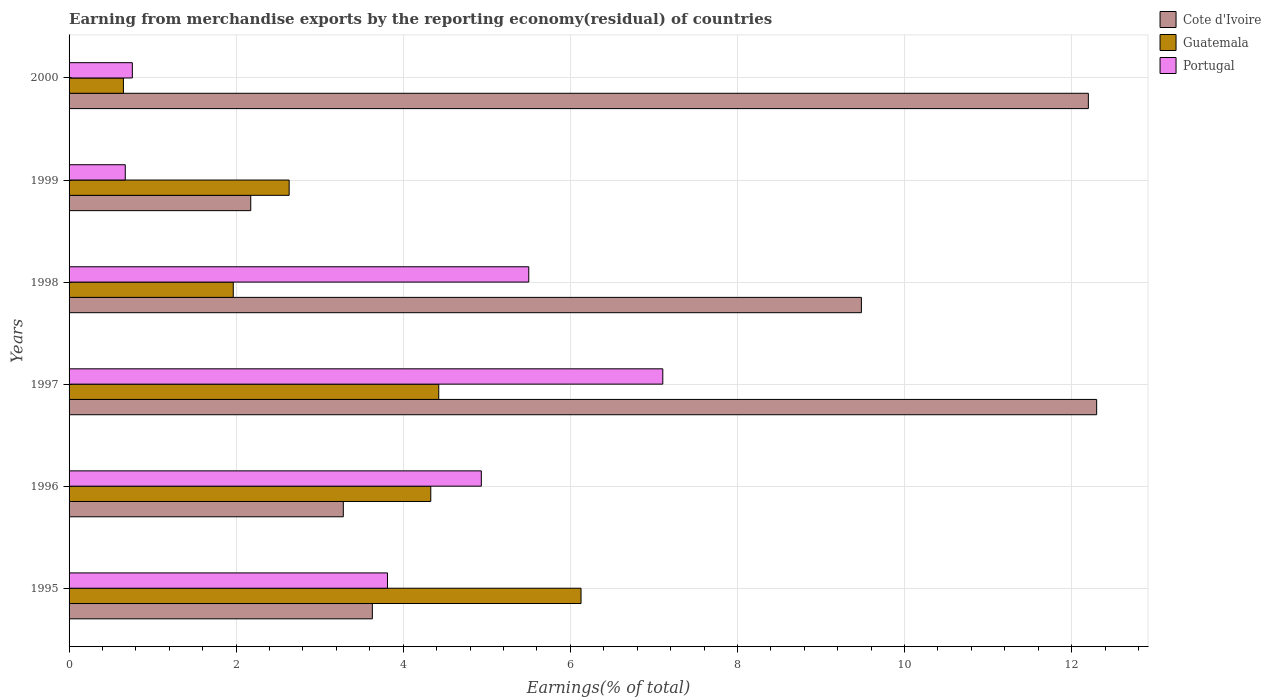How many different coloured bars are there?
Keep it short and to the point. 3. Are the number of bars on each tick of the Y-axis equal?
Offer a very short reply. Yes. How many bars are there on the 4th tick from the top?
Your response must be concise. 3. How many bars are there on the 1st tick from the bottom?
Your answer should be compact. 3. What is the label of the 3rd group of bars from the top?
Offer a terse response. 1998. In how many cases, is the number of bars for a given year not equal to the number of legend labels?
Provide a short and direct response. 0. What is the percentage of amount earned from merchandise exports in Guatemala in 1997?
Keep it short and to the point. 4.43. Across all years, what is the maximum percentage of amount earned from merchandise exports in Portugal?
Offer a very short reply. 7.11. Across all years, what is the minimum percentage of amount earned from merchandise exports in Portugal?
Offer a very short reply. 0.67. In which year was the percentage of amount earned from merchandise exports in Guatemala maximum?
Provide a short and direct response. 1995. In which year was the percentage of amount earned from merchandise exports in Guatemala minimum?
Provide a succinct answer. 2000. What is the total percentage of amount earned from merchandise exports in Guatemala in the graph?
Ensure brevity in your answer.  20.13. What is the difference between the percentage of amount earned from merchandise exports in Cote d'Ivoire in 1998 and that in 1999?
Ensure brevity in your answer.  7.31. What is the difference between the percentage of amount earned from merchandise exports in Guatemala in 1996 and the percentage of amount earned from merchandise exports in Cote d'Ivoire in 1998?
Your answer should be compact. -5.15. What is the average percentage of amount earned from merchandise exports in Portugal per year?
Make the answer very short. 3.8. In the year 1996, what is the difference between the percentage of amount earned from merchandise exports in Cote d'Ivoire and percentage of amount earned from merchandise exports in Portugal?
Give a very brief answer. -1.65. What is the ratio of the percentage of amount earned from merchandise exports in Guatemala in 1998 to that in 2000?
Ensure brevity in your answer.  3.02. Is the percentage of amount earned from merchandise exports in Guatemala in 1998 less than that in 2000?
Your answer should be compact. No. What is the difference between the highest and the second highest percentage of amount earned from merchandise exports in Portugal?
Offer a very short reply. 1.6. What is the difference between the highest and the lowest percentage of amount earned from merchandise exports in Portugal?
Provide a succinct answer. 6.43. In how many years, is the percentage of amount earned from merchandise exports in Guatemala greater than the average percentage of amount earned from merchandise exports in Guatemala taken over all years?
Your answer should be compact. 3. What does the 3rd bar from the top in 1998 represents?
Keep it short and to the point. Cote d'Ivoire. What does the 1st bar from the bottom in 1996 represents?
Your answer should be compact. Cote d'Ivoire. Is it the case that in every year, the sum of the percentage of amount earned from merchandise exports in Cote d'Ivoire and percentage of amount earned from merchandise exports in Portugal is greater than the percentage of amount earned from merchandise exports in Guatemala?
Keep it short and to the point. Yes. Are all the bars in the graph horizontal?
Keep it short and to the point. Yes. What is the difference between two consecutive major ticks on the X-axis?
Keep it short and to the point. 2. Are the values on the major ticks of X-axis written in scientific E-notation?
Offer a terse response. No. Does the graph contain any zero values?
Your answer should be very brief. No. Does the graph contain grids?
Make the answer very short. Yes. How many legend labels are there?
Make the answer very short. 3. What is the title of the graph?
Make the answer very short. Earning from merchandise exports by the reporting economy(residual) of countries. Does "Saudi Arabia" appear as one of the legend labels in the graph?
Provide a succinct answer. No. What is the label or title of the X-axis?
Offer a very short reply. Earnings(% of total). What is the Earnings(% of total) in Cote d'Ivoire in 1995?
Offer a terse response. 3.63. What is the Earnings(% of total) in Guatemala in 1995?
Keep it short and to the point. 6.13. What is the Earnings(% of total) in Portugal in 1995?
Your answer should be very brief. 3.81. What is the Earnings(% of total) in Cote d'Ivoire in 1996?
Offer a very short reply. 3.28. What is the Earnings(% of total) in Guatemala in 1996?
Give a very brief answer. 4.33. What is the Earnings(% of total) in Portugal in 1996?
Ensure brevity in your answer.  4.93. What is the Earnings(% of total) of Cote d'Ivoire in 1997?
Offer a terse response. 12.3. What is the Earnings(% of total) of Guatemala in 1997?
Offer a very short reply. 4.43. What is the Earnings(% of total) of Portugal in 1997?
Keep it short and to the point. 7.11. What is the Earnings(% of total) in Cote d'Ivoire in 1998?
Offer a terse response. 9.48. What is the Earnings(% of total) of Guatemala in 1998?
Ensure brevity in your answer.  1.97. What is the Earnings(% of total) of Portugal in 1998?
Your answer should be compact. 5.5. What is the Earnings(% of total) of Cote d'Ivoire in 1999?
Make the answer very short. 2.17. What is the Earnings(% of total) in Guatemala in 1999?
Offer a terse response. 2.63. What is the Earnings(% of total) in Portugal in 1999?
Ensure brevity in your answer.  0.67. What is the Earnings(% of total) of Cote d'Ivoire in 2000?
Ensure brevity in your answer.  12.2. What is the Earnings(% of total) of Guatemala in 2000?
Your answer should be very brief. 0.65. What is the Earnings(% of total) of Portugal in 2000?
Your response must be concise. 0.76. Across all years, what is the maximum Earnings(% of total) of Cote d'Ivoire?
Offer a very short reply. 12.3. Across all years, what is the maximum Earnings(% of total) of Guatemala?
Your response must be concise. 6.13. Across all years, what is the maximum Earnings(% of total) of Portugal?
Keep it short and to the point. 7.11. Across all years, what is the minimum Earnings(% of total) in Cote d'Ivoire?
Keep it short and to the point. 2.17. Across all years, what is the minimum Earnings(% of total) in Guatemala?
Offer a terse response. 0.65. Across all years, what is the minimum Earnings(% of total) in Portugal?
Keep it short and to the point. 0.67. What is the total Earnings(% of total) of Cote d'Ivoire in the graph?
Keep it short and to the point. 43.07. What is the total Earnings(% of total) in Guatemala in the graph?
Provide a succinct answer. 20.13. What is the total Earnings(% of total) in Portugal in the graph?
Ensure brevity in your answer.  22.79. What is the difference between the Earnings(% of total) in Cote d'Ivoire in 1995 and that in 1996?
Provide a succinct answer. 0.35. What is the difference between the Earnings(% of total) in Guatemala in 1995 and that in 1996?
Ensure brevity in your answer.  1.8. What is the difference between the Earnings(% of total) of Portugal in 1995 and that in 1996?
Make the answer very short. -1.12. What is the difference between the Earnings(% of total) in Cote d'Ivoire in 1995 and that in 1997?
Provide a succinct answer. -8.67. What is the difference between the Earnings(% of total) in Guatemala in 1995 and that in 1997?
Ensure brevity in your answer.  1.7. What is the difference between the Earnings(% of total) of Portugal in 1995 and that in 1997?
Ensure brevity in your answer.  -3.3. What is the difference between the Earnings(% of total) of Cote d'Ivoire in 1995 and that in 1998?
Keep it short and to the point. -5.85. What is the difference between the Earnings(% of total) of Guatemala in 1995 and that in 1998?
Offer a terse response. 4.16. What is the difference between the Earnings(% of total) in Portugal in 1995 and that in 1998?
Offer a very short reply. -1.69. What is the difference between the Earnings(% of total) of Cote d'Ivoire in 1995 and that in 1999?
Offer a very short reply. 1.46. What is the difference between the Earnings(% of total) of Guatemala in 1995 and that in 1999?
Your answer should be compact. 3.49. What is the difference between the Earnings(% of total) of Portugal in 1995 and that in 1999?
Keep it short and to the point. 3.14. What is the difference between the Earnings(% of total) in Cote d'Ivoire in 1995 and that in 2000?
Your answer should be very brief. -8.57. What is the difference between the Earnings(% of total) in Guatemala in 1995 and that in 2000?
Provide a succinct answer. 5.48. What is the difference between the Earnings(% of total) in Portugal in 1995 and that in 2000?
Provide a short and direct response. 3.05. What is the difference between the Earnings(% of total) of Cote d'Ivoire in 1996 and that in 1997?
Provide a short and direct response. -9.02. What is the difference between the Earnings(% of total) of Guatemala in 1996 and that in 1997?
Keep it short and to the point. -0.1. What is the difference between the Earnings(% of total) in Portugal in 1996 and that in 1997?
Provide a succinct answer. -2.17. What is the difference between the Earnings(% of total) in Cote d'Ivoire in 1996 and that in 1998?
Ensure brevity in your answer.  -6.2. What is the difference between the Earnings(% of total) of Guatemala in 1996 and that in 1998?
Offer a terse response. 2.36. What is the difference between the Earnings(% of total) in Portugal in 1996 and that in 1998?
Provide a short and direct response. -0.57. What is the difference between the Earnings(% of total) of Cote d'Ivoire in 1996 and that in 1999?
Offer a terse response. 1.11. What is the difference between the Earnings(% of total) of Guatemala in 1996 and that in 1999?
Your answer should be very brief. 1.7. What is the difference between the Earnings(% of total) of Portugal in 1996 and that in 1999?
Keep it short and to the point. 4.26. What is the difference between the Earnings(% of total) in Cote d'Ivoire in 1996 and that in 2000?
Provide a succinct answer. -8.92. What is the difference between the Earnings(% of total) in Guatemala in 1996 and that in 2000?
Your answer should be very brief. 3.68. What is the difference between the Earnings(% of total) in Portugal in 1996 and that in 2000?
Ensure brevity in your answer.  4.18. What is the difference between the Earnings(% of total) in Cote d'Ivoire in 1997 and that in 1998?
Give a very brief answer. 2.82. What is the difference between the Earnings(% of total) of Guatemala in 1997 and that in 1998?
Give a very brief answer. 2.46. What is the difference between the Earnings(% of total) in Portugal in 1997 and that in 1998?
Keep it short and to the point. 1.6. What is the difference between the Earnings(% of total) of Cote d'Ivoire in 1997 and that in 1999?
Provide a succinct answer. 10.13. What is the difference between the Earnings(% of total) in Guatemala in 1997 and that in 1999?
Make the answer very short. 1.79. What is the difference between the Earnings(% of total) in Portugal in 1997 and that in 1999?
Give a very brief answer. 6.43. What is the difference between the Earnings(% of total) in Cote d'Ivoire in 1997 and that in 2000?
Your answer should be compact. 0.1. What is the difference between the Earnings(% of total) in Guatemala in 1997 and that in 2000?
Keep it short and to the point. 3.77. What is the difference between the Earnings(% of total) in Portugal in 1997 and that in 2000?
Give a very brief answer. 6.35. What is the difference between the Earnings(% of total) of Cote d'Ivoire in 1998 and that in 1999?
Your answer should be compact. 7.31. What is the difference between the Earnings(% of total) of Guatemala in 1998 and that in 1999?
Make the answer very short. -0.67. What is the difference between the Earnings(% of total) in Portugal in 1998 and that in 1999?
Ensure brevity in your answer.  4.83. What is the difference between the Earnings(% of total) of Cote d'Ivoire in 1998 and that in 2000?
Offer a terse response. -2.72. What is the difference between the Earnings(% of total) of Guatemala in 1998 and that in 2000?
Keep it short and to the point. 1.31. What is the difference between the Earnings(% of total) of Portugal in 1998 and that in 2000?
Offer a very short reply. 4.75. What is the difference between the Earnings(% of total) of Cote d'Ivoire in 1999 and that in 2000?
Your answer should be compact. -10.03. What is the difference between the Earnings(% of total) of Guatemala in 1999 and that in 2000?
Your answer should be very brief. 1.98. What is the difference between the Earnings(% of total) in Portugal in 1999 and that in 2000?
Ensure brevity in your answer.  -0.08. What is the difference between the Earnings(% of total) in Cote d'Ivoire in 1995 and the Earnings(% of total) in Guatemala in 1996?
Your answer should be compact. -0.7. What is the difference between the Earnings(% of total) of Cote d'Ivoire in 1995 and the Earnings(% of total) of Portugal in 1996?
Provide a succinct answer. -1.3. What is the difference between the Earnings(% of total) in Guatemala in 1995 and the Earnings(% of total) in Portugal in 1996?
Provide a short and direct response. 1.19. What is the difference between the Earnings(% of total) of Cote d'Ivoire in 1995 and the Earnings(% of total) of Guatemala in 1997?
Offer a very short reply. -0.79. What is the difference between the Earnings(% of total) of Cote d'Ivoire in 1995 and the Earnings(% of total) of Portugal in 1997?
Ensure brevity in your answer.  -3.48. What is the difference between the Earnings(% of total) of Guatemala in 1995 and the Earnings(% of total) of Portugal in 1997?
Give a very brief answer. -0.98. What is the difference between the Earnings(% of total) of Cote d'Ivoire in 1995 and the Earnings(% of total) of Guatemala in 1998?
Offer a very short reply. 1.66. What is the difference between the Earnings(% of total) in Cote d'Ivoire in 1995 and the Earnings(% of total) in Portugal in 1998?
Provide a short and direct response. -1.87. What is the difference between the Earnings(% of total) in Guatemala in 1995 and the Earnings(% of total) in Portugal in 1998?
Your answer should be compact. 0.63. What is the difference between the Earnings(% of total) of Cote d'Ivoire in 1995 and the Earnings(% of total) of Portugal in 1999?
Keep it short and to the point. 2.96. What is the difference between the Earnings(% of total) in Guatemala in 1995 and the Earnings(% of total) in Portugal in 1999?
Provide a succinct answer. 5.46. What is the difference between the Earnings(% of total) in Cote d'Ivoire in 1995 and the Earnings(% of total) in Guatemala in 2000?
Ensure brevity in your answer.  2.98. What is the difference between the Earnings(% of total) in Cote d'Ivoire in 1995 and the Earnings(% of total) in Portugal in 2000?
Provide a succinct answer. 2.87. What is the difference between the Earnings(% of total) of Guatemala in 1995 and the Earnings(% of total) of Portugal in 2000?
Give a very brief answer. 5.37. What is the difference between the Earnings(% of total) of Cote d'Ivoire in 1996 and the Earnings(% of total) of Guatemala in 1997?
Keep it short and to the point. -1.14. What is the difference between the Earnings(% of total) of Cote d'Ivoire in 1996 and the Earnings(% of total) of Portugal in 1997?
Ensure brevity in your answer.  -3.82. What is the difference between the Earnings(% of total) in Guatemala in 1996 and the Earnings(% of total) in Portugal in 1997?
Offer a very short reply. -2.78. What is the difference between the Earnings(% of total) of Cote d'Ivoire in 1996 and the Earnings(% of total) of Guatemala in 1998?
Keep it short and to the point. 1.32. What is the difference between the Earnings(% of total) in Cote d'Ivoire in 1996 and the Earnings(% of total) in Portugal in 1998?
Ensure brevity in your answer.  -2.22. What is the difference between the Earnings(% of total) in Guatemala in 1996 and the Earnings(% of total) in Portugal in 1998?
Offer a very short reply. -1.17. What is the difference between the Earnings(% of total) in Cote d'Ivoire in 1996 and the Earnings(% of total) in Guatemala in 1999?
Make the answer very short. 0.65. What is the difference between the Earnings(% of total) in Cote d'Ivoire in 1996 and the Earnings(% of total) in Portugal in 1999?
Your answer should be compact. 2.61. What is the difference between the Earnings(% of total) of Guatemala in 1996 and the Earnings(% of total) of Portugal in 1999?
Ensure brevity in your answer.  3.66. What is the difference between the Earnings(% of total) in Cote d'Ivoire in 1996 and the Earnings(% of total) in Guatemala in 2000?
Your answer should be very brief. 2.63. What is the difference between the Earnings(% of total) of Cote d'Ivoire in 1996 and the Earnings(% of total) of Portugal in 2000?
Offer a terse response. 2.53. What is the difference between the Earnings(% of total) in Guatemala in 1996 and the Earnings(% of total) in Portugal in 2000?
Give a very brief answer. 3.57. What is the difference between the Earnings(% of total) in Cote d'Ivoire in 1997 and the Earnings(% of total) in Guatemala in 1998?
Provide a succinct answer. 10.33. What is the difference between the Earnings(% of total) in Cote d'Ivoire in 1997 and the Earnings(% of total) in Portugal in 1998?
Provide a short and direct response. 6.8. What is the difference between the Earnings(% of total) of Guatemala in 1997 and the Earnings(% of total) of Portugal in 1998?
Ensure brevity in your answer.  -1.08. What is the difference between the Earnings(% of total) of Cote d'Ivoire in 1997 and the Earnings(% of total) of Guatemala in 1999?
Make the answer very short. 9.67. What is the difference between the Earnings(% of total) in Cote d'Ivoire in 1997 and the Earnings(% of total) in Portugal in 1999?
Ensure brevity in your answer.  11.63. What is the difference between the Earnings(% of total) in Guatemala in 1997 and the Earnings(% of total) in Portugal in 1999?
Keep it short and to the point. 3.75. What is the difference between the Earnings(% of total) in Cote d'Ivoire in 1997 and the Earnings(% of total) in Guatemala in 2000?
Ensure brevity in your answer.  11.65. What is the difference between the Earnings(% of total) in Cote d'Ivoire in 1997 and the Earnings(% of total) in Portugal in 2000?
Your response must be concise. 11.54. What is the difference between the Earnings(% of total) in Guatemala in 1997 and the Earnings(% of total) in Portugal in 2000?
Give a very brief answer. 3.67. What is the difference between the Earnings(% of total) of Cote d'Ivoire in 1998 and the Earnings(% of total) of Guatemala in 1999?
Provide a succinct answer. 6.85. What is the difference between the Earnings(% of total) of Cote d'Ivoire in 1998 and the Earnings(% of total) of Portugal in 1999?
Make the answer very short. 8.81. What is the difference between the Earnings(% of total) of Guatemala in 1998 and the Earnings(% of total) of Portugal in 1999?
Provide a short and direct response. 1.29. What is the difference between the Earnings(% of total) in Cote d'Ivoire in 1998 and the Earnings(% of total) in Guatemala in 2000?
Make the answer very short. 8.83. What is the difference between the Earnings(% of total) of Cote d'Ivoire in 1998 and the Earnings(% of total) of Portugal in 2000?
Your answer should be compact. 8.73. What is the difference between the Earnings(% of total) of Guatemala in 1998 and the Earnings(% of total) of Portugal in 2000?
Offer a very short reply. 1.21. What is the difference between the Earnings(% of total) of Cote d'Ivoire in 1999 and the Earnings(% of total) of Guatemala in 2000?
Offer a very short reply. 1.52. What is the difference between the Earnings(% of total) of Cote d'Ivoire in 1999 and the Earnings(% of total) of Portugal in 2000?
Make the answer very short. 1.42. What is the difference between the Earnings(% of total) in Guatemala in 1999 and the Earnings(% of total) in Portugal in 2000?
Offer a terse response. 1.88. What is the average Earnings(% of total) of Cote d'Ivoire per year?
Your answer should be compact. 7.18. What is the average Earnings(% of total) of Guatemala per year?
Make the answer very short. 3.36. What is the average Earnings(% of total) of Portugal per year?
Keep it short and to the point. 3.8. In the year 1995, what is the difference between the Earnings(% of total) of Cote d'Ivoire and Earnings(% of total) of Guatemala?
Offer a very short reply. -2.5. In the year 1995, what is the difference between the Earnings(% of total) of Cote d'Ivoire and Earnings(% of total) of Portugal?
Give a very brief answer. -0.18. In the year 1995, what is the difference between the Earnings(% of total) in Guatemala and Earnings(% of total) in Portugal?
Your response must be concise. 2.32. In the year 1996, what is the difference between the Earnings(% of total) of Cote d'Ivoire and Earnings(% of total) of Guatemala?
Your answer should be compact. -1.05. In the year 1996, what is the difference between the Earnings(% of total) of Cote d'Ivoire and Earnings(% of total) of Portugal?
Keep it short and to the point. -1.65. In the year 1996, what is the difference between the Earnings(% of total) in Guatemala and Earnings(% of total) in Portugal?
Ensure brevity in your answer.  -0.6. In the year 1997, what is the difference between the Earnings(% of total) of Cote d'Ivoire and Earnings(% of total) of Guatemala?
Your answer should be very brief. 7.88. In the year 1997, what is the difference between the Earnings(% of total) in Cote d'Ivoire and Earnings(% of total) in Portugal?
Your answer should be very brief. 5.19. In the year 1997, what is the difference between the Earnings(% of total) in Guatemala and Earnings(% of total) in Portugal?
Ensure brevity in your answer.  -2.68. In the year 1998, what is the difference between the Earnings(% of total) in Cote d'Ivoire and Earnings(% of total) in Guatemala?
Offer a terse response. 7.52. In the year 1998, what is the difference between the Earnings(% of total) of Cote d'Ivoire and Earnings(% of total) of Portugal?
Your answer should be very brief. 3.98. In the year 1998, what is the difference between the Earnings(% of total) of Guatemala and Earnings(% of total) of Portugal?
Offer a terse response. -3.54. In the year 1999, what is the difference between the Earnings(% of total) in Cote d'Ivoire and Earnings(% of total) in Guatemala?
Give a very brief answer. -0.46. In the year 1999, what is the difference between the Earnings(% of total) in Cote d'Ivoire and Earnings(% of total) in Portugal?
Offer a very short reply. 1.5. In the year 1999, what is the difference between the Earnings(% of total) of Guatemala and Earnings(% of total) of Portugal?
Provide a succinct answer. 1.96. In the year 2000, what is the difference between the Earnings(% of total) of Cote d'Ivoire and Earnings(% of total) of Guatemala?
Provide a succinct answer. 11.55. In the year 2000, what is the difference between the Earnings(% of total) in Cote d'Ivoire and Earnings(% of total) in Portugal?
Provide a short and direct response. 11.44. In the year 2000, what is the difference between the Earnings(% of total) in Guatemala and Earnings(% of total) in Portugal?
Your answer should be compact. -0.11. What is the ratio of the Earnings(% of total) in Cote d'Ivoire in 1995 to that in 1996?
Ensure brevity in your answer.  1.11. What is the ratio of the Earnings(% of total) in Guatemala in 1995 to that in 1996?
Offer a very short reply. 1.42. What is the ratio of the Earnings(% of total) of Portugal in 1995 to that in 1996?
Your answer should be very brief. 0.77. What is the ratio of the Earnings(% of total) of Cote d'Ivoire in 1995 to that in 1997?
Offer a very short reply. 0.3. What is the ratio of the Earnings(% of total) in Guatemala in 1995 to that in 1997?
Offer a very short reply. 1.38. What is the ratio of the Earnings(% of total) of Portugal in 1995 to that in 1997?
Offer a terse response. 0.54. What is the ratio of the Earnings(% of total) in Cote d'Ivoire in 1995 to that in 1998?
Offer a very short reply. 0.38. What is the ratio of the Earnings(% of total) in Guatemala in 1995 to that in 1998?
Offer a very short reply. 3.12. What is the ratio of the Earnings(% of total) of Portugal in 1995 to that in 1998?
Your answer should be very brief. 0.69. What is the ratio of the Earnings(% of total) of Cote d'Ivoire in 1995 to that in 1999?
Keep it short and to the point. 1.67. What is the ratio of the Earnings(% of total) in Guatemala in 1995 to that in 1999?
Ensure brevity in your answer.  2.33. What is the ratio of the Earnings(% of total) of Portugal in 1995 to that in 1999?
Offer a terse response. 5.67. What is the ratio of the Earnings(% of total) in Cote d'Ivoire in 1995 to that in 2000?
Offer a very short reply. 0.3. What is the ratio of the Earnings(% of total) in Guatemala in 1995 to that in 2000?
Your answer should be very brief. 9.42. What is the ratio of the Earnings(% of total) in Portugal in 1995 to that in 2000?
Your response must be concise. 5.03. What is the ratio of the Earnings(% of total) of Cote d'Ivoire in 1996 to that in 1997?
Offer a very short reply. 0.27. What is the ratio of the Earnings(% of total) in Guatemala in 1996 to that in 1997?
Provide a short and direct response. 0.98. What is the ratio of the Earnings(% of total) in Portugal in 1996 to that in 1997?
Provide a succinct answer. 0.69. What is the ratio of the Earnings(% of total) of Cote d'Ivoire in 1996 to that in 1998?
Your response must be concise. 0.35. What is the ratio of the Earnings(% of total) of Guatemala in 1996 to that in 1998?
Make the answer very short. 2.2. What is the ratio of the Earnings(% of total) in Portugal in 1996 to that in 1998?
Your answer should be compact. 0.9. What is the ratio of the Earnings(% of total) of Cote d'Ivoire in 1996 to that in 1999?
Provide a succinct answer. 1.51. What is the ratio of the Earnings(% of total) of Guatemala in 1996 to that in 1999?
Ensure brevity in your answer.  1.64. What is the ratio of the Earnings(% of total) in Portugal in 1996 to that in 1999?
Your response must be concise. 7.33. What is the ratio of the Earnings(% of total) of Cote d'Ivoire in 1996 to that in 2000?
Your answer should be very brief. 0.27. What is the ratio of the Earnings(% of total) of Guatemala in 1996 to that in 2000?
Offer a very short reply. 6.65. What is the ratio of the Earnings(% of total) in Portugal in 1996 to that in 2000?
Offer a terse response. 6.51. What is the ratio of the Earnings(% of total) of Cote d'Ivoire in 1997 to that in 1998?
Offer a very short reply. 1.3. What is the ratio of the Earnings(% of total) in Guatemala in 1997 to that in 1998?
Keep it short and to the point. 2.25. What is the ratio of the Earnings(% of total) in Portugal in 1997 to that in 1998?
Offer a very short reply. 1.29. What is the ratio of the Earnings(% of total) of Cote d'Ivoire in 1997 to that in 1999?
Ensure brevity in your answer.  5.66. What is the ratio of the Earnings(% of total) of Guatemala in 1997 to that in 1999?
Keep it short and to the point. 1.68. What is the ratio of the Earnings(% of total) of Portugal in 1997 to that in 1999?
Your answer should be very brief. 10.56. What is the ratio of the Earnings(% of total) in Cote d'Ivoire in 1997 to that in 2000?
Keep it short and to the point. 1.01. What is the ratio of the Earnings(% of total) in Guatemala in 1997 to that in 2000?
Ensure brevity in your answer.  6.8. What is the ratio of the Earnings(% of total) of Portugal in 1997 to that in 2000?
Provide a short and direct response. 9.38. What is the ratio of the Earnings(% of total) in Cote d'Ivoire in 1998 to that in 1999?
Ensure brevity in your answer.  4.36. What is the ratio of the Earnings(% of total) in Guatemala in 1998 to that in 1999?
Your response must be concise. 0.75. What is the ratio of the Earnings(% of total) of Portugal in 1998 to that in 1999?
Your answer should be compact. 8.18. What is the ratio of the Earnings(% of total) in Cote d'Ivoire in 1998 to that in 2000?
Provide a succinct answer. 0.78. What is the ratio of the Earnings(% of total) of Guatemala in 1998 to that in 2000?
Ensure brevity in your answer.  3.02. What is the ratio of the Earnings(% of total) of Portugal in 1998 to that in 2000?
Your answer should be very brief. 7.26. What is the ratio of the Earnings(% of total) in Cote d'Ivoire in 1999 to that in 2000?
Offer a terse response. 0.18. What is the ratio of the Earnings(% of total) in Guatemala in 1999 to that in 2000?
Your answer should be very brief. 4.05. What is the ratio of the Earnings(% of total) in Portugal in 1999 to that in 2000?
Your answer should be very brief. 0.89. What is the difference between the highest and the second highest Earnings(% of total) in Cote d'Ivoire?
Your answer should be very brief. 0.1. What is the difference between the highest and the second highest Earnings(% of total) in Guatemala?
Provide a short and direct response. 1.7. What is the difference between the highest and the second highest Earnings(% of total) in Portugal?
Your response must be concise. 1.6. What is the difference between the highest and the lowest Earnings(% of total) of Cote d'Ivoire?
Offer a terse response. 10.13. What is the difference between the highest and the lowest Earnings(% of total) of Guatemala?
Provide a succinct answer. 5.48. What is the difference between the highest and the lowest Earnings(% of total) of Portugal?
Provide a short and direct response. 6.43. 